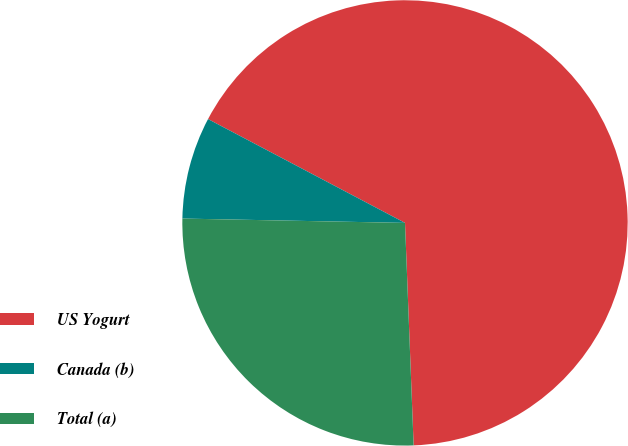Convert chart. <chart><loc_0><loc_0><loc_500><loc_500><pie_chart><fcel>US Yogurt<fcel>Canada (b)<fcel>Total (a)<nl><fcel>66.67%<fcel>7.41%<fcel>25.93%<nl></chart> 